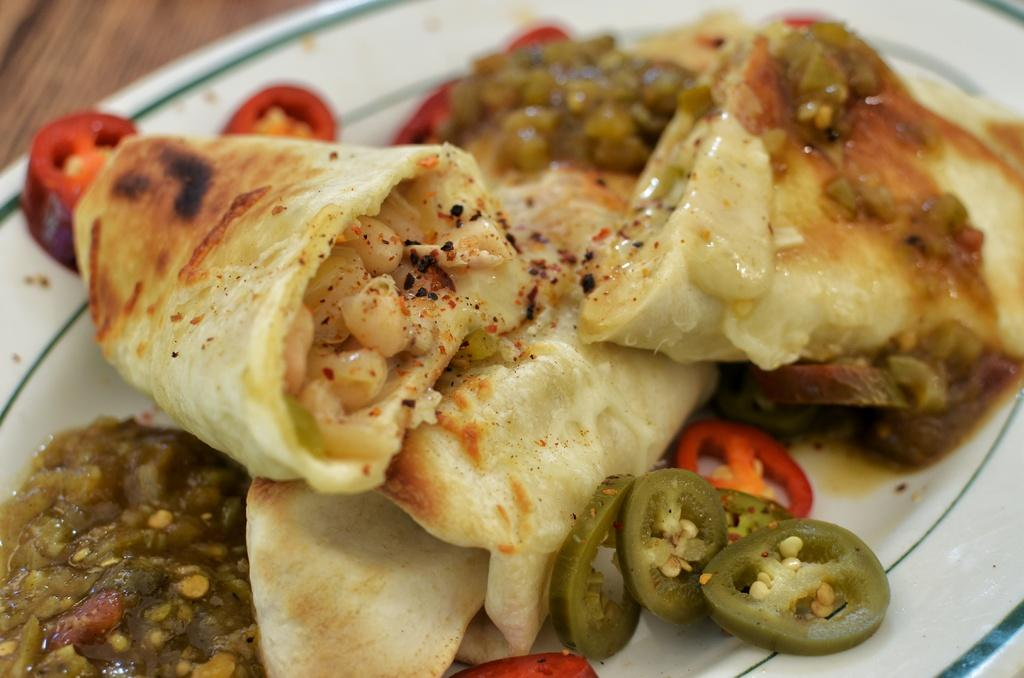What piece of furniture is visible in the image? There is a table in the image. What is placed on the table? There is a plate on the table. What is on the plate? There is a food item on the plate. How many cows are tied with a knot in the image? There are no cows or knots present in the image. 